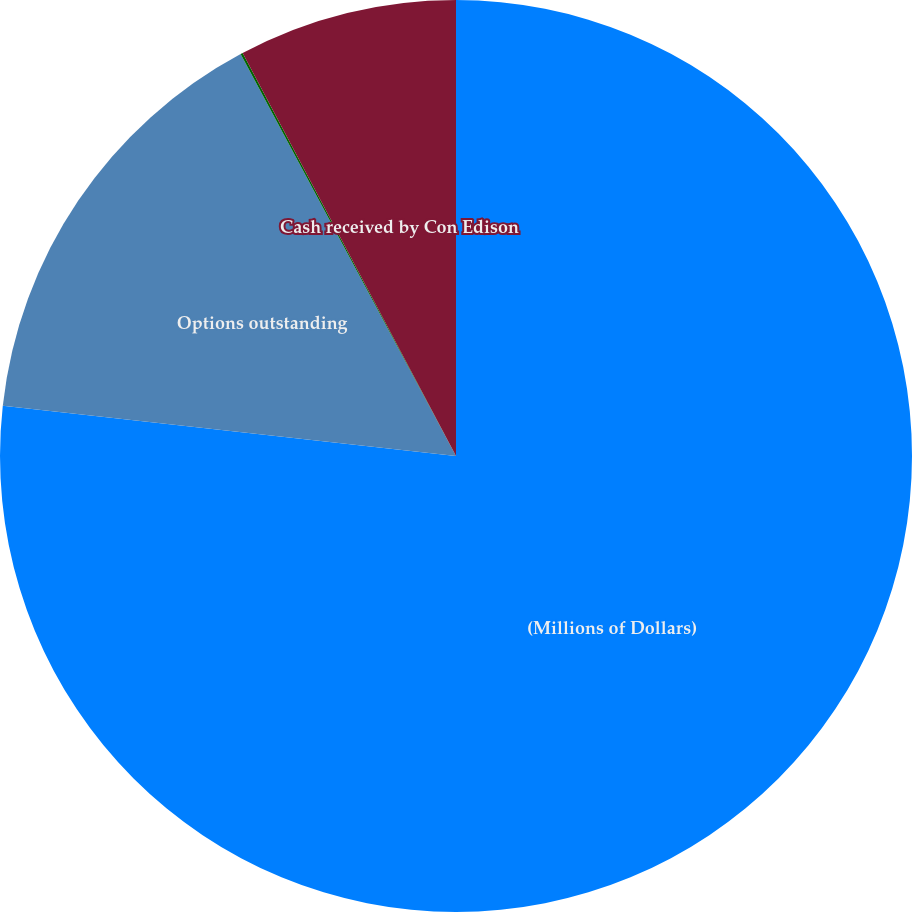Convert chart to OTSL. <chart><loc_0><loc_0><loc_500><loc_500><pie_chart><fcel>(Millions of Dollars)<fcel>Options outstanding<fcel>Options exercised<fcel>Cash received by Con Edison<nl><fcel>76.76%<fcel>15.41%<fcel>0.08%<fcel>7.75%<nl></chart> 